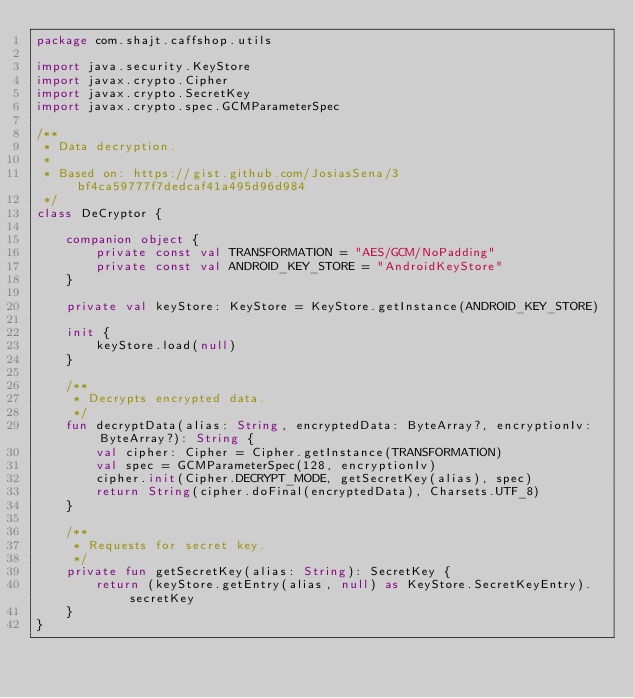<code> <loc_0><loc_0><loc_500><loc_500><_Kotlin_>package com.shajt.caffshop.utils

import java.security.KeyStore
import javax.crypto.Cipher
import javax.crypto.SecretKey
import javax.crypto.spec.GCMParameterSpec

/**
 * Data decryption.
 *
 * Based on: https://gist.github.com/JosiasSena/3bf4ca59777f7dedcaf41a495d96d984
 */
class DeCryptor {

    companion object {
        private const val TRANSFORMATION = "AES/GCM/NoPadding"
        private const val ANDROID_KEY_STORE = "AndroidKeyStore"
    }

    private val keyStore: KeyStore = KeyStore.getInstance(ANDROID_KEY_STORE)

    init {
        keyStore.load(null)
    }

    /**
     * Decrypts encrypted data.
     */
    fun decryptData(alias: String, encryptedData: ByteArray?, encryptionIv: ByteArray?): String {
        val cipher: Cipher = Cipher.getInstance(TRANSFORMATION)
        val spec = GCMParameterSpec(128, encryptionIv)
        cipher.init(Cipher.DECRYPT_MODE, getSecretKey(alias), spec)
        return String(cipher.doFinal(encryptedData), Charsets.UTF_8)
    }

    /**
     * Requests for secret key.
     */
    private fun getSecretKey(alias: String): SecretKey {
        return (keyStore.getEntry(alias, null) as KeyStore.SecretKeyEntry).secretKey
    }
}</code> 